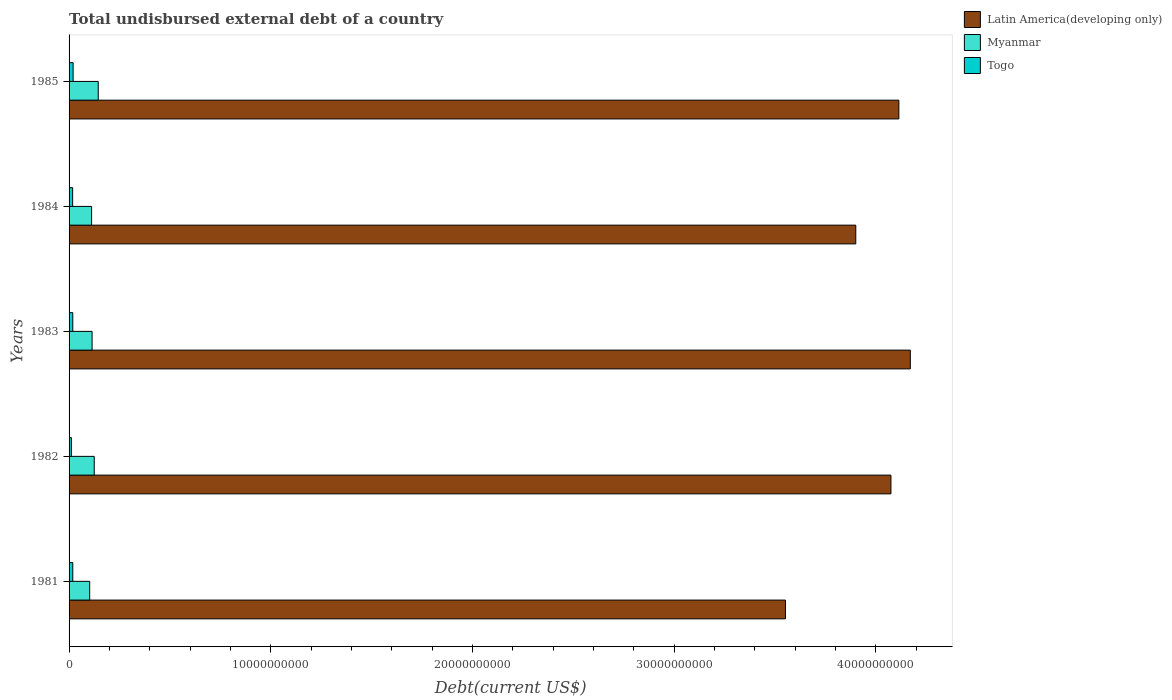How many different coloured bars are there?
Your answer should be very brief. 3. How many groups of bars are there?
Your answer should be very brief. 5. Are the number of bars per tick equal to the number of legend labels?
Ensure brevity in your answer.  Yes. How many bars are there on the 5th tick from the bottom?
Offer a terse response. 3. In how many cases, is the number of bars for a given year not equal to the number of legend labels?
Make the answer very short. 0. What is the total undisbursed external debt in Latin America(developing only) in 1982?
Make the answer very short. 4.08e+1. Across all years, what is the maximum total undisbursed external debt in Togo?
Make the answer very short. 2.00e+08. Across all years, what is the minimum total undisbursed external debt in Myanmar?
Your response must be concise. 1.02e+09. What is the total total undisbursed external debt in Togo in the graph?
Offer a terse response. 8.61e+08. What is the difference between the total undisbursed external debt in Latin America(developing only) in 1982 and that in 1984?
Your response must be concise. 1.74e+09. What is the difference between the total undisbursed external debt in Togo in 1985 and the total undisbursed external debt in Latin America(developing only) in 1983?
Ensure brevity in your answer.  -4.15e+1. What is the average total undisbursed external debt in Latin America(developing only) per year?
Ensure brevity in your answer.  3.96e+1. In the year 1981, what is the difference between the total undisbursed external debt in Togo and total undisbursed external debt in Latin America(developing only)?
Ensure brevity in your answer.  -3.53e+1. In how many years, is the total undisbursed external debt in Latin America(developing only) greater than 38000000000 US$?
Make the answer very short. 4. What is the ratio of the total undisbursed external debt in Latin America(developing only) in 1984 to that in 1985?
Offer a terse response. 0.95. Is the total undisbursed external debt in Togo in 1981 less than that in 1982?
Offer a very short reply. No. What is the difference between the highest and the second highest total undisbursed external debt in Togo?
Offer a very short reply. 1.60e+07. What is the difference between the highest and the lowest total undisbursed external debt in Latin America(developing only)?
Make the answer very short. 6.19e+09. Is the sum of the total undisbursed external debt in Latin America(developing only) in 1984 and 1985 greater than the maximum total undisbursed external debt in Togo across all years?
Make the answer very short. Yes. What does the 2nd bar from the top in 1982 represents?
Your answer should be very brief. Myanmar. What does the 2nd bar from the bottom in 1984 represents?
Your answer should be compact. Myanmar. Is it the case that in every year, the sum of the total undisbursed external debt in Togo and total undisbursed external debt in Latin America(developing only) is greater than the total undisbursed external debt in Myanmar?
Your response must be concise. Yes. How many bars are there?
Your answer should be very brief. 15. How many years are there in the graph?
Give a very brief answer. 5. Does the graph contain any zero values?
Give a very brief answer. No. Does the graph contain grids?
Make the answer very short. No. Where does the legend appear in the graph?
Keep it short and to the point. Top right. How are the legend labels stacked?
Offer a terse response. Vertical. What is the title of the graph?
Provide a short and direct response. Total undisbursed external debt of a country. Does "Namibia" appear as one of the legend labels in the graph?
Make the answer very short. No. What is the label or title of the X-axis?
Provide a short and direct response. Debt(current US$). What is the Debt(current US$) of Latin America(developing only) in 1981?
Keep it short and to the point. 3.55e+1. What is the Debt(current US$) in Myanmar in 1981?
Give a very brief answer. 1.02e+09. What is the Debt(current US$) of Togo in 1981?
Your answer should be compact. 1.84e+08. What is the Debt(current US$) of Latin America(developing only) in 1982?
Your answer should be very brief. 4.08e+1. What is the Debt(current US$) of Myanmar in 1982?
Keep it short and to the point. 1.25e+09. What is the Debt(current US$) in Togo in 1982?
Your answer should be compact. 1.16e+08. What is the Debt(current US$) in Latin America(developing only) in 1983?
Your answer should be compact. 4.17e+1. What is the Debt(current US$) in Myanmar in 1983?
Offer a terse response. 1.14e+09. What is the Debt(current US$) of Togo in 1983?
Offer a terse response. 1.84e+08. What is the Debt(current US$) in Latin America(developing only) in 1984?
Make the answer very short. 3.90e+1. What is the Debt(current US$) in Myanmar in 1984?
Your answer should be compact. 1.12e+09. What is the Debt(current US$) in Togo in 1984?
Keep it short and to the point. 1.77e+08. What is the Debt(current US$) of Latin America(developing only) in 1985?
Give a very brief answer. 4.11e+1. What is the Debt(current US$) of Myanmar in 1985?
Keep it short and to the point. 1.45e+09. What is the Debt(current US$) in Togo in 1985?
Make the answer very short. 2.00e+08. Across all years, what is the maximum Debt(current US$) in Latin America(developing only)?
Offer a very short reply. 4.17e+1. Across all years, what is the maximum Debt(current US$) of Myanmar?
Your answer should be compact. 1.45e+09. Across all years, what is the maximum Debt(current US$) of Togo?
Your answer should be compact. 2.00e+08. Across all years, what is the minimum Debt(current US$) in Latin America(developing only)?
Offer a terse response. 3.55e+1. Across all years, what is the minimum Debt(current US$) of Myanmar?
Provide a succinct answer. 1.02e+09. Across all years, what is the minimum Debt(current US$) of Togo?
Make the answer very short. 1.16e+08. What is the total Debt(current US$) of Latin America(developing only) in the graph?
Offer a terse response. 1.98e+11. What is the total Debt(current US$) in Myanmar in the graph?
Give a very brief answer. 5.98e+09. What is the total Debt(current US$) of Togo in the graph?
Provide a succinct answer. 8.61e+08. What is the difference between the Debt(current US$) in Latin America(developing only) in 1981 and that in 1982?
Your answer should be compact. -5.23e+09. What is the difference between the Debt(current US$) of Myanmar in 1981 and that in 1982?
Offer a very short reply. -2.25e+08. What is the difference between the Debt(current US$) of Togo in 1981 and that in 1982?
Make the answer very short. 6.80e+07. What is the difference between the Debt(current US$) of Latin America(developing only) in 1981 and that in 1983?
Your response must be concise. -6.19e+09. What is the difference between the Debt(current US$) of Myanmar in 1981 and that in 1983?
Make the answer very short. -1.19e+08. What is the difference between the Debt(current US$) in Togo in 1981 and that in 1983?
Make the answer very short. -4.61e+05. What is the difference between the Debt(current US$) in Latin America(developing only) in 1981 and that in 1984?
Offer a very short reply. -3.49e+09. What is the difference between the Debt(current US$) of Myanmar in 1981 and that in 1984?
Provide a short and direct response. -9.45e+07. What is the difference between the Debt(current US$) of Togo in 1981 and that in 1984?
Your answer should be compact. 6.75e+06. What is the difference between the Debt(current US$) in Latin America(developing only) in 1981 and that in 1985?
Your response must be concise. -5.62e+09. What is the difference between the Debt(current US$) in Myanmar in 1981 and that in 1985?
Make the answer very short. -4.24e+08. What is the difference between the Debt(current US$) in Togo in 1981 and that in 1985?
Offer a very short reply. -1.65e+07. What is the difference between the Debt(current US$) of Latin America(developing only) in 1982 and that in 1983?
Your response must be concise. -9.61e+08. What is the difference between the Debt(current US$) of Myanmar in 1982 and that in 1983?
Make the answer very short. 1.07e+08. What is the difference between the Debt(current US$) in Togo in 1982 and that in 1983?
Give a very brief answer. -6.85e+07. What is the difference between the Debt(current US$) of Latin America(developing only) in 1982 and that in 1984?
Provide a succinct answer. 1.74e+09. What is the difference between the Debt(current US$) in Myanmar in 1982 and that in 1984?
Offer a terse response. 1.31e+08. What is the difference between the Debt(current US$) of Togo in 1982 and that in 1984?
Provide a short and direct response. -6.13e+07. What is the difference between the Debt(current US$) of Latin America(developing only) in 1982 and that in 1985?
Provide a short and direct response. -3.93e+08. What is the difference between the Debt(current US$) of Myanmar in 1982 and that in 1985?
Give a very brief answer. -1.99e+08. What is the difference between the Debt(current US$) of Togo in 1982 and that in 1985?
Your answer should be compact. -8.46e+07. What is the difference between the Debt(current US$) of Latin America(developing only) in 1983 and that in 1984?
Your answer should be very brief. 2.70e+09. What is the difference between the Debt(current US$) in Myanmar in 1983 and that in 1984?
Offer a very short reply. 2.40e+07. What is the difference between the Debt(current US$) of Togo in 1983 and that in 1984?
Your answer should be very brief. 7.21e+06. What is the difference between the Debt(current US$) of Latin America(developing only) in 1983 and that in 1985?
Provide a short and direct response. 5.68e+08. What is the difference between the Debt(current US$) of Myanmar in 1983 and that in 1985?
Offer a terse response. -3.06e+08. What is the difference between the Debt(current US$) in Togo in 1983 and that in 1985?
Keep it short and to the point. -1.60e+07. What is the difference between the Debt(current US$) of Latin America(developing only) in 1984 and that in 1985?
Provide a succinct answer. -2.14e+09. What is the difference between the Debt(current US$) in Myanmar in 1984 and that in 1985?
Your answer should be compact. -3.30e+08. What is the difference between the Debt(current US$) in Togo in 1984 and that in 1985?
Make the answer very short. -2.33e+07. What is the difference between the Debt(current US$) in Latin America(developing only) in 1981 and the Debt(current US$) in Myanmar in 1982?
Give a very brief answer. 3.43e+1. What is the difference between the Debt(current US$) of Latin America(developing only) in 1981 and the Debt(current US$) of Togo in 1982?
Keep it short and to the point. 3.54e+1. What is the difference between the Debt(current US$) of Myanmar in 1981 and the Debt(current US$) of Togo in 1982?
Offer a terse response. 9.07e+08. What is the difference between the Debt(current US$) of Latin America(developing only) in 1981 and the Debt(current US$) of Myanmar in 1983?
Offer a terse response. 3.44e+1. What is the difference between the Debt(current US$) of Latin America(developing only) in 1981 and the Debt(current US$) of Togo in 1983?
Keep it short and to the point. 3.53e+1. What is the difference between the Debt(current US$) of Myanmar in 1981 and the Debt(current US$) of Togo in 1983?
Your answer should be compact. 8.38e+08. What is the difference between the Debt(current US$) in Latin America(developing only) in 1981 and the Debt(current US$) in Myanmar in 1984?
Provide a short and direct response. 3.44e+1. What is the difference between the Debt(current US$) in Latin America(developing only) in 1981 and the Debt(current US$) in Togo in 1984?
Give a very brief answer. 3.53e+1. What is the difference between the Debt(current US$) in Myanmar in 1981 and the Debt(current US$) in Togo in 1984?
Your response must be concise. 8.46e+08. What is the difference between the Debt(current US$) in Latin America(developing only) in 1981 and the Debt(current US$) in Myanmar in 1985?
Your answer should be compact. 3.41e+1. What is the difference between the Debt(current US$) in Latin America(developing only) in 1981 and the Debt(current US$) in Togo in 1985?
Give a very brief answer. 3.53e+1. What is the difference between the Debt(current US$) in Myanmar in 1981 and the Debt(current US$) in Togo in 1985?
Keep it short and to the point. 8.22e+08. What is the difference between the Debt(current US$) of Latin America(developing only) in 1982 and the Debt(current US$) of Myanmar in 1983?
Your response must be concise. 3.96e+1. What is the difference between the Debt(current US$) in Latin America(developing only) in 1982 and the Debt(current US$) in Togo in 1983?
Offer a terse response. 4.06e+1. What is the difference between the Debt(current US$) in Myanmar in 1982 and the Debt(current US$) in Togo in 1983?
Give a very brief answer. 1.06e+09. What is the difference between the Debt(current US$) of Latin America(developing only) in 1982 and the Debt(current US$) of Myanmar in 1984?
Offer a very short reply. 3.96e+1. What is the difference between the Debt(current US$) of Latin America(developing only) in 1982 and the Debt(current US$) of Togo in 1984?
Make the answer very short. 4.06e+1. What is the difference between the Debt(current US$) of Myanmar in 1982 and the Debt(current US$) of Togo in 1984?
Offer a terse response. 1.07e+09. What is the difference between the Debt(current US$) of Latin America(developing only) in 1982 and the Debt(current US$) of Myanmar in 1985?
Provide a succinct answer. 3.93e+1. What is the difference between the Debt(current US$) of Latin America(developing only) in 1982 and the Debt(current US$) of Togo in 1985?
Make the answer very short. 4.06e+1. What is the difference between the Debt(current US$) of Myanmar in 1982 and the Debt(current US$) of Togo in 1985?
Your response must be concise. 1.05e+09. What is the difference between the Debt(current US$) of Latin America(developing only) in 1983 and the Debt(current US$) of Myanmar in 1984?
Your response must be concise. 4.06e+1. What is the difference between the Debt(current US$) of Latin America(developing only) in 1983 and the Debt(current US$) of Togo in 1984?
Your response must be concise. 4.15e+1. What is the difference between the Debt(current US$) of Myanmar in 1983 and the Debt(current US$) of Togo in 1984?
Provide a succinct answer. 9.64e+08. What is the difference between the Debt(current US$) of Latin America(developing only) in 1983 and the Debt(current US$) of Myanmar in 1985?
Make the answer very short. 4.03e+1. What is the difference between the Debt(current US$) in Latin America(developing only) in 1983 and the Debt(current US$) in Togo in 1985?
Offer a very short reply. 4.15e+1. What is the difference between the Debt(current US$) in Myanmar in 1983 and the Debt(current US$) in Togo in 1985?
Give a very brief answer. 9.41e+08. What is the difference between the Debt(current US$) in Latin America(developing only) in 1984 and the Debt(current US$) in Myanmar in 1985?
Make the answer very short. 3.76e+1. What is the difference between the Debt(current US$) of Latin America(developing only) in 1984 and the Debt(current US$) of Togo in 1985?
Your response must be concise. 3.88e+1. What is the difference between the Debt(current US$) in Myanmar in 1984 and the Debt(current US$) in Togo in 1985?
Make the answer very short. 9.17e+08. What is the average Debt(current US$) of Latin America(developing only) per year?
Offer a terse response. 3.96e+1. What is the average Debt(current US$) in Myanmar per year?
Your response must be concise. 1.20e+09. What is the average Debt(current US$) of Togo per year?
Provide a succinct answer. 1.72e+08. In the year 1981, what is the difference between the Debt(current US$) of Latin America(developing only) and Debt(current US$) of Myanmar?
Your answer should be very brief. 3.45e+1. In the year 1981, what is the difference between the Debt(current US$) in Latin America(developing only) and Debt(current US$) in Togo?
Offer a terse response. 3.53e+1. In the year 1981, what is the difference between the Debt(current US$) of Myanmar and Debt(current US$) of Togo?
Provide a short and direct response. 8.39e+08. In the year 1982, what is the difference between the Debt(current US$) of Latin America(developing only) and Debt(current US$) of Myanmar?
Give a very brief answer. 3.95e+1. In the year 1982, what is the difference between the Debt(current US$) of Latin America(developing only) and Debt(current US$) of Togo?
Your response must be concise. 4.06e+1. In the year 1982, what is the difference between the Debt(current US$) in Myanmar and Debt(current US$) in Togo?
Offer a very short reply. 1.13e+09. In the year 1983, what is the difference between the Debt(current US$) of Latin America(developing only) and Debt(current US$) of Myanmar?
Provide a short and direct response. 4.06e+1. In the year 1983, what is the difference between the Debt(current US$) of Latin America(developing only) and Debt(current US$) of Togo?
Your answer should be very brief. 4.15e+1. In the year 1983, what is the difference between the Debt(current US$) in Myanmar and Debt(current US$) in Togo?
Keep it short and to the point. 9.57e+08. In the year 1984, what is the difference between the Debt(current US$) in Latin America(developing only) and Debt(current US$) in Myanmar?
Make the answer very short. 3.79e+1. In the year 1984, what is the difference between the Debt(current US$) in Latin America(developing only) and Debt(current US$) in Togo?
Give a very brief answer. 3.88e+1. In the year 1984, what is the difference between the Debt(current US$) in Myanmar and Debt(current US$) in Togo?
Offer a very short reply. 9.40e+08. In the year 1985, what is the difference between the Debt(current US$) of Latin America(developing only) and Debt(current US$) of Myanmar?
Your answer should be very brief. 3.97e+1. In the year 1985, what is the difference between the Debt(current US$) of Latin America(developing only) and Debt(current US$) of Togo?
Offer a terse response. 4.09e+1. In the year 1985, what is the difference between the Debt(current US$) in Myanmar and Debt(current US$) in Togo?
Your response must be concise. 1.25e+09. What is the ratio of the Debt(current US$) of Latin America(developing only) in 1981 to that in 1982?
Provide a short and direct response. 0.87. What is the ratio of the Debt(current US$) of Myanmar in 1981 to that in 1982?
Make the answer very short. 0.82. What is the ratio of the Debt(current US$) of Togo in 1981 to that in 1982?
Offer a terse response. 1.59. What is the ratio of the Debt(current US$) of Latin America(developing only) in 1981 to that in 1983?
Provide a succinct answer. 0.85. What is the ratio of the Debt(current US$) in Myanmar in 1981 to that in 1983?
Your response must be concise. 0.9. What is the ratio of the Debt(current US$) of Latin America(developing only) in 1981 to that in 1984?
Your answer should be compact. 0.91. What is the ratio of the Debt(current US$) in Myanmar in 1981 to that in 1984?
Make the answer very short. 0.92. What is the ratio of the Debt(current US$) of Togo in 1981 to that in 1984?
Your answer should be very brief. 1.04. What is the ratio of the Debt(current US$) of Latin America(developing only) in 1981 to that in 1985?
Keep it short and to the point. 0.86. What is the ratio of the Debt(current US$) in Myanmar in 1981 to that in 1985?
Provide a short and direct response. 0.71. What is the ratio of the Debt(current US$) of Togo in 1981 to that in 1985?
Ensure brevity in your answer.  0.92. What is the ratio of the Debt(current US$) in Myanmar in 1982 to that in 1983?
Make the answer very short. 1.09. What is the ratio of the Debt(current US$) of Togo in 1982 to that in 1983?
Your answer should be compact. 0.63. What is the ratio of the Debt(current US$) in Latin America(developing only) in 1982 to that in 1984?
Offer a very short reply. 1.04. What is the ratio of the Debt(current US$) of Myanmar in 1982 to that in 1984?
Give a very brief answer. 1.12. What is the ratio of the Debt(current US$) in Togo in 1982 to that in 1984?
Offer a terse response. 0.65. What is the ratio of the Debt(current US$) of Latin America(developing only) in 1982 to that in 1985?
Provide a short and direct response. 0.99. What is the ratio of the Debt(current US$) in Myanmar in 1982 to that in 1985?
Make the answer very short. 0.86. What is the ratio of the Debt(current US$) in Togo in 1982 to that in 1985?
Provide a succinct answer. 0.58. What is the ratio of the Debt(current US$) in Latin America(developing only) in 1983 to that in 1984?
Offer a very short reply. 1.07. What is the ratio of the Debt(current US$) in Myanmar in 1983 to that in 1984?
Offer a terse response. 1.02. What is the ratio of the Debt(current US$) of Togo in 1983 to that in 1984?
Make the answer very short. 1.04. What is the ratio of the Debt(current US$) of Latin America(developing only) in 1983 to that in 1985?
Keep it short and to the point. 1.01. What is the ratio of the Debt(current US$) in Myanmar in 1983 to that in 1985?
Keep it short and to the point. 0.79. What is the ratio of the Debt(current US$) in Togo in 1983 to that in 1985?
Your answer should be very brief. 0.92. What is the ratio of the Debt(current US$) in Latin America(developing only) in 1984 to that in 1985?
Give a very brief answer. 0.95. What is the ratio of the Debt(current US$) of Myanmar in 1984 to that in 1985?
Your answer should be compact. 0.77. What is the ratio of the Debt(current US$) in Togo in 1984 to that in 1985?
Offer a very short reply. 0.88. What is the difference between the highest and the second highest Debt(current US$) in Latin America(developing only)?
Give a very brief answer. 5.68e+08. What is the difference between the highest and the second highest Debt(current US$) in Myanmar?
Your response must be concise. 1.99e+08. What is the difference between the highest and the second highest Debt(current US$) in Togo?
Give a very brief answer. 1.60e+07. What is the difference between the highest and the lowest Debt(current US$) of Latin America(developing only)?
Your answer should be very brief. 6.19e+09. What is the difference between the highest and the lowest Debt(current US$) of Myanmar?
Offer a very short reply. 4.24e+08. What is the difference between the highest and the lowest Debt(current US$) in Togo?
Give a very brief answer. 8.46e+07. 